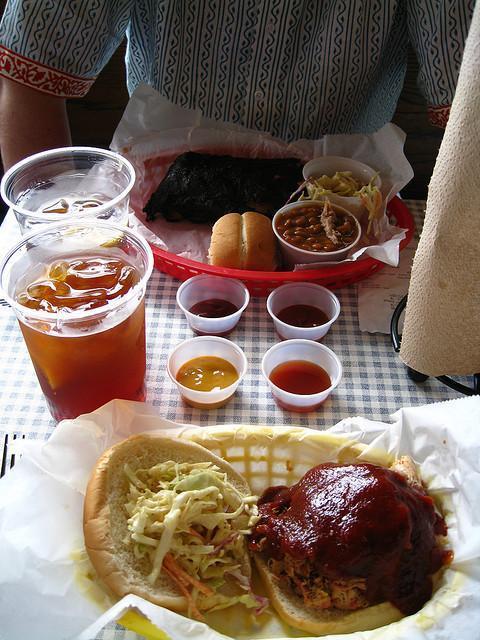How many dining tables can you see?
Give a very brief answer. 1. How many cups can you see?
Give a very brief answer. 7. How many bowls are there?
Give a very brief answer. 6. How many sandwiches can you see?
Give a very brief answer. 3. How many zebras have their faces showing in the image?
Give a very brief answer. 0. 